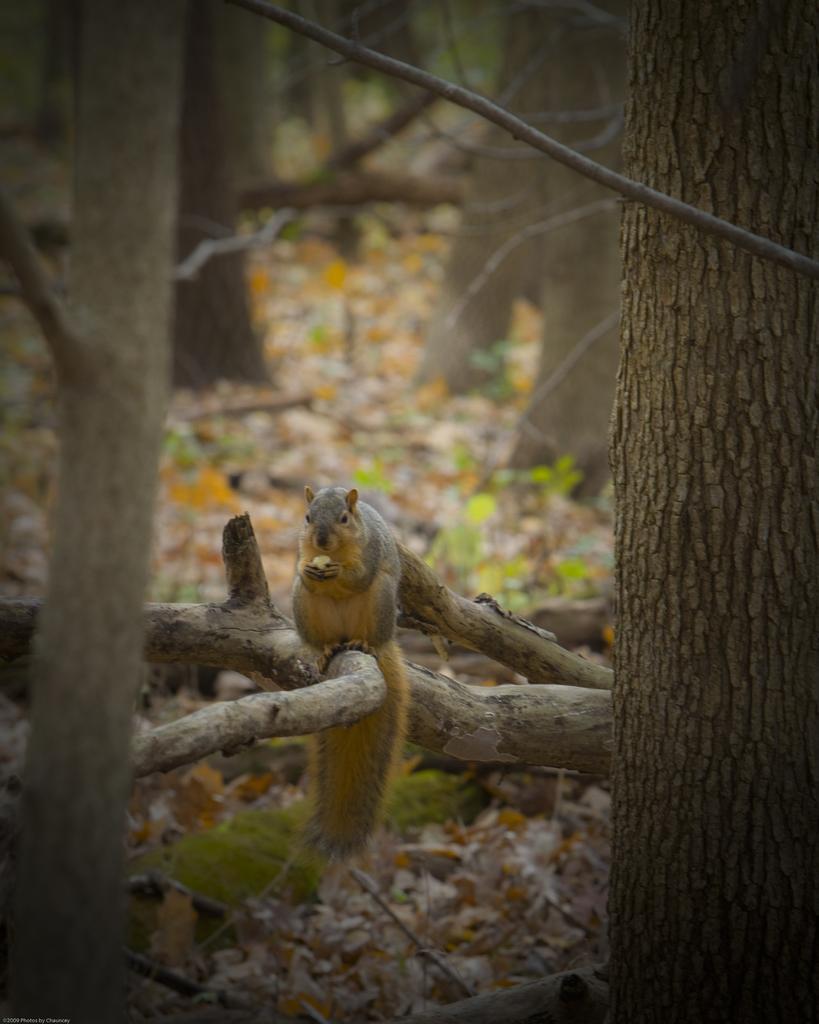Can you describe this image briefly? In the image there are trees and there is a squirrel sitting on the branch of one tree. 